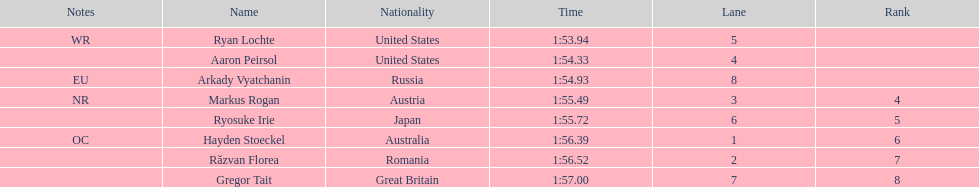Does russia or japan have the longer time? Japan. 